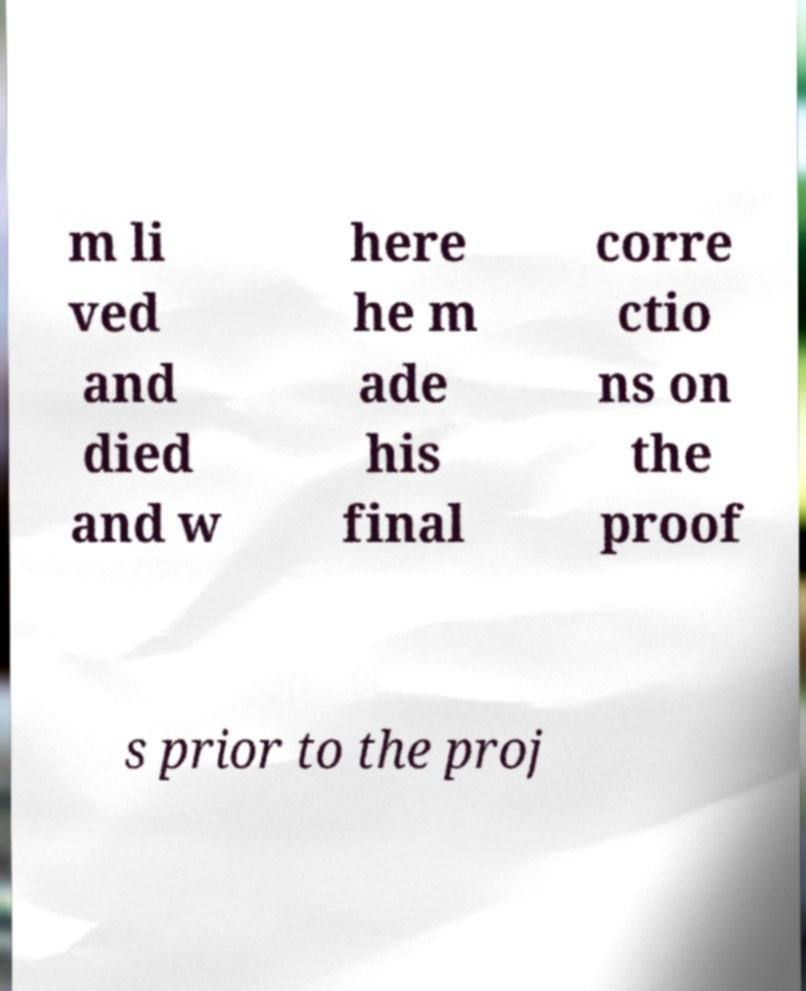Please identify and transcribe the text found in this image. m li ved and died and w here he m ade his final corre ctio ns on the proof s prior to the proj 